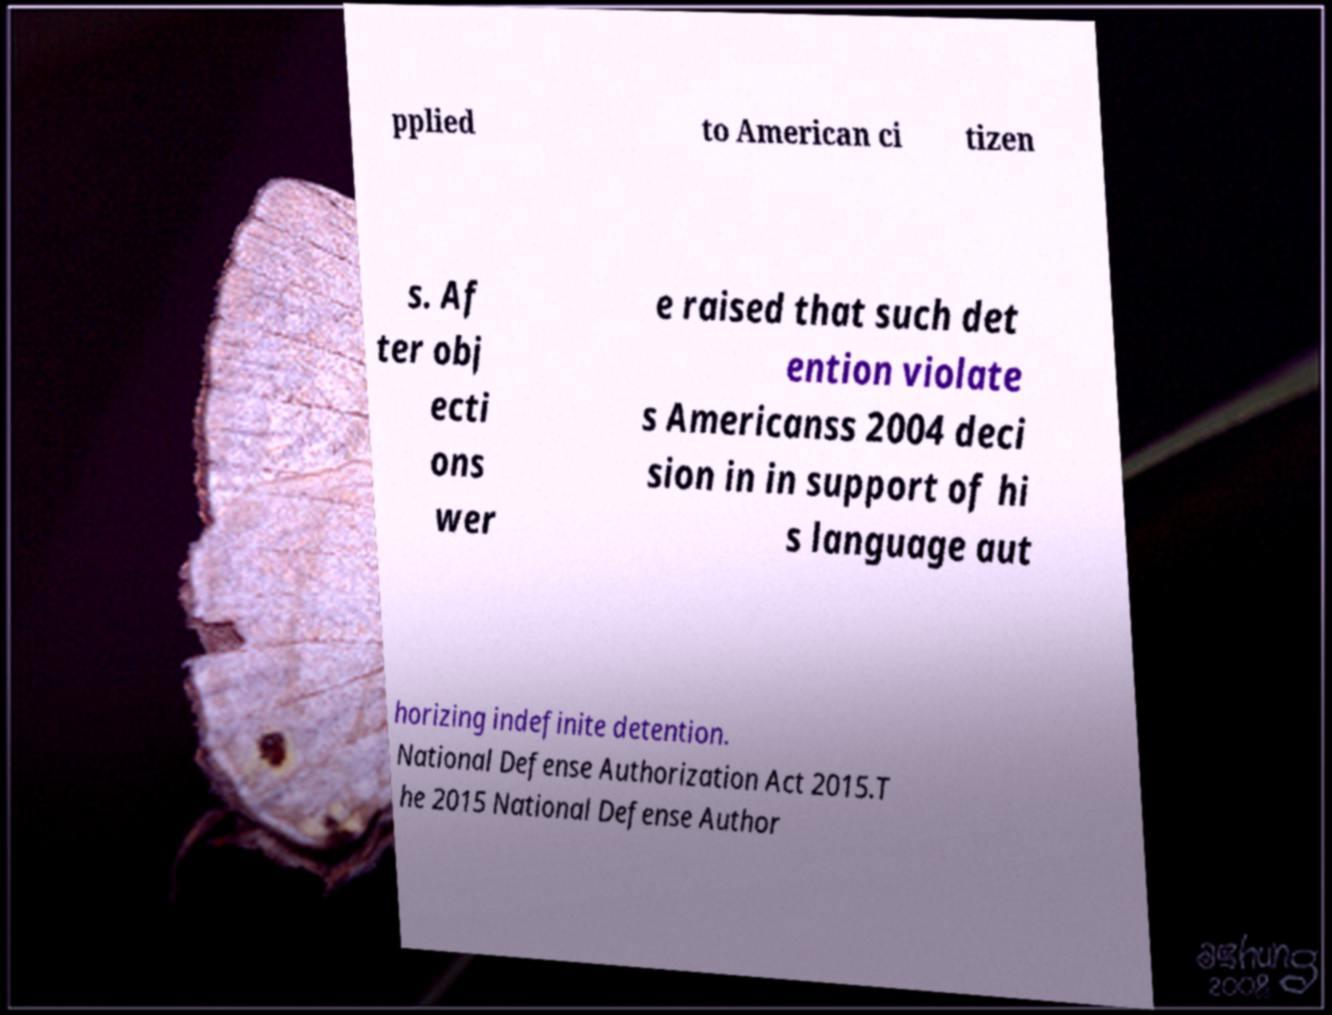Please identify and transcribe the text found in this image. pplied to American ci tizen s. Af ter obj ecti ons wer e raised that such det ention violate s Americanss 2004 deci sion in in support of hi s language aut horizing indefinite detention. National Defense Authorization Act 2015.T he 2015 National Defense Author 